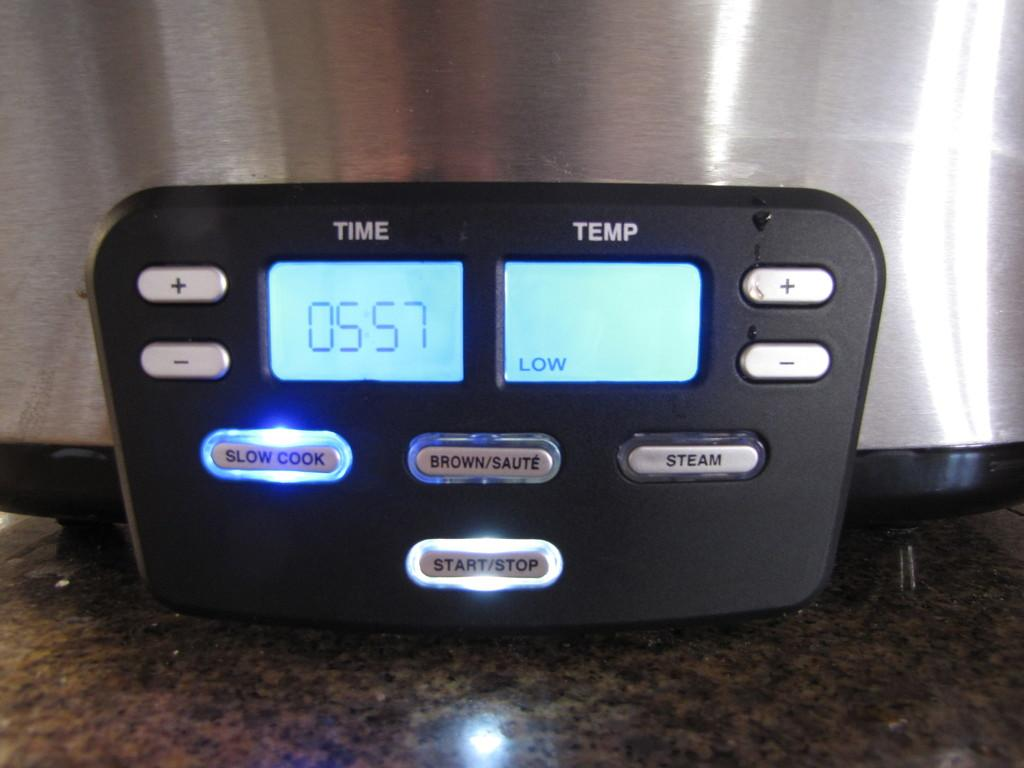<image>
Create a compact narrative representing the image presented. A digital display readong 0557 for a slow cooker 